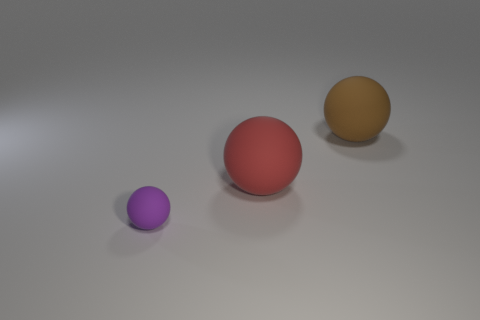Subtract all tiny purple matte balls. How many balls are left? 2 Subtract 2 balls. How many balls are left? 1 Subtract all brown balls. How many balls are left? 2 Subtract 0 green spheres. How many objects are left? 3 Subtract all blue balls. Subtract all yellow cylinders. How many balls are left? 3 Subtract all cyan cylinders. How many brown balls are left? 1 Subtract all gray shiny objects. Subtract all large things. How many objects are left? 1 Add 2 brown matte balls. How many brown matte balls are left? 3 Add 1 purple matte things. How many purple matte things exist? 2 Add 1 large purple matte cylinders. How many objects exist? 4 